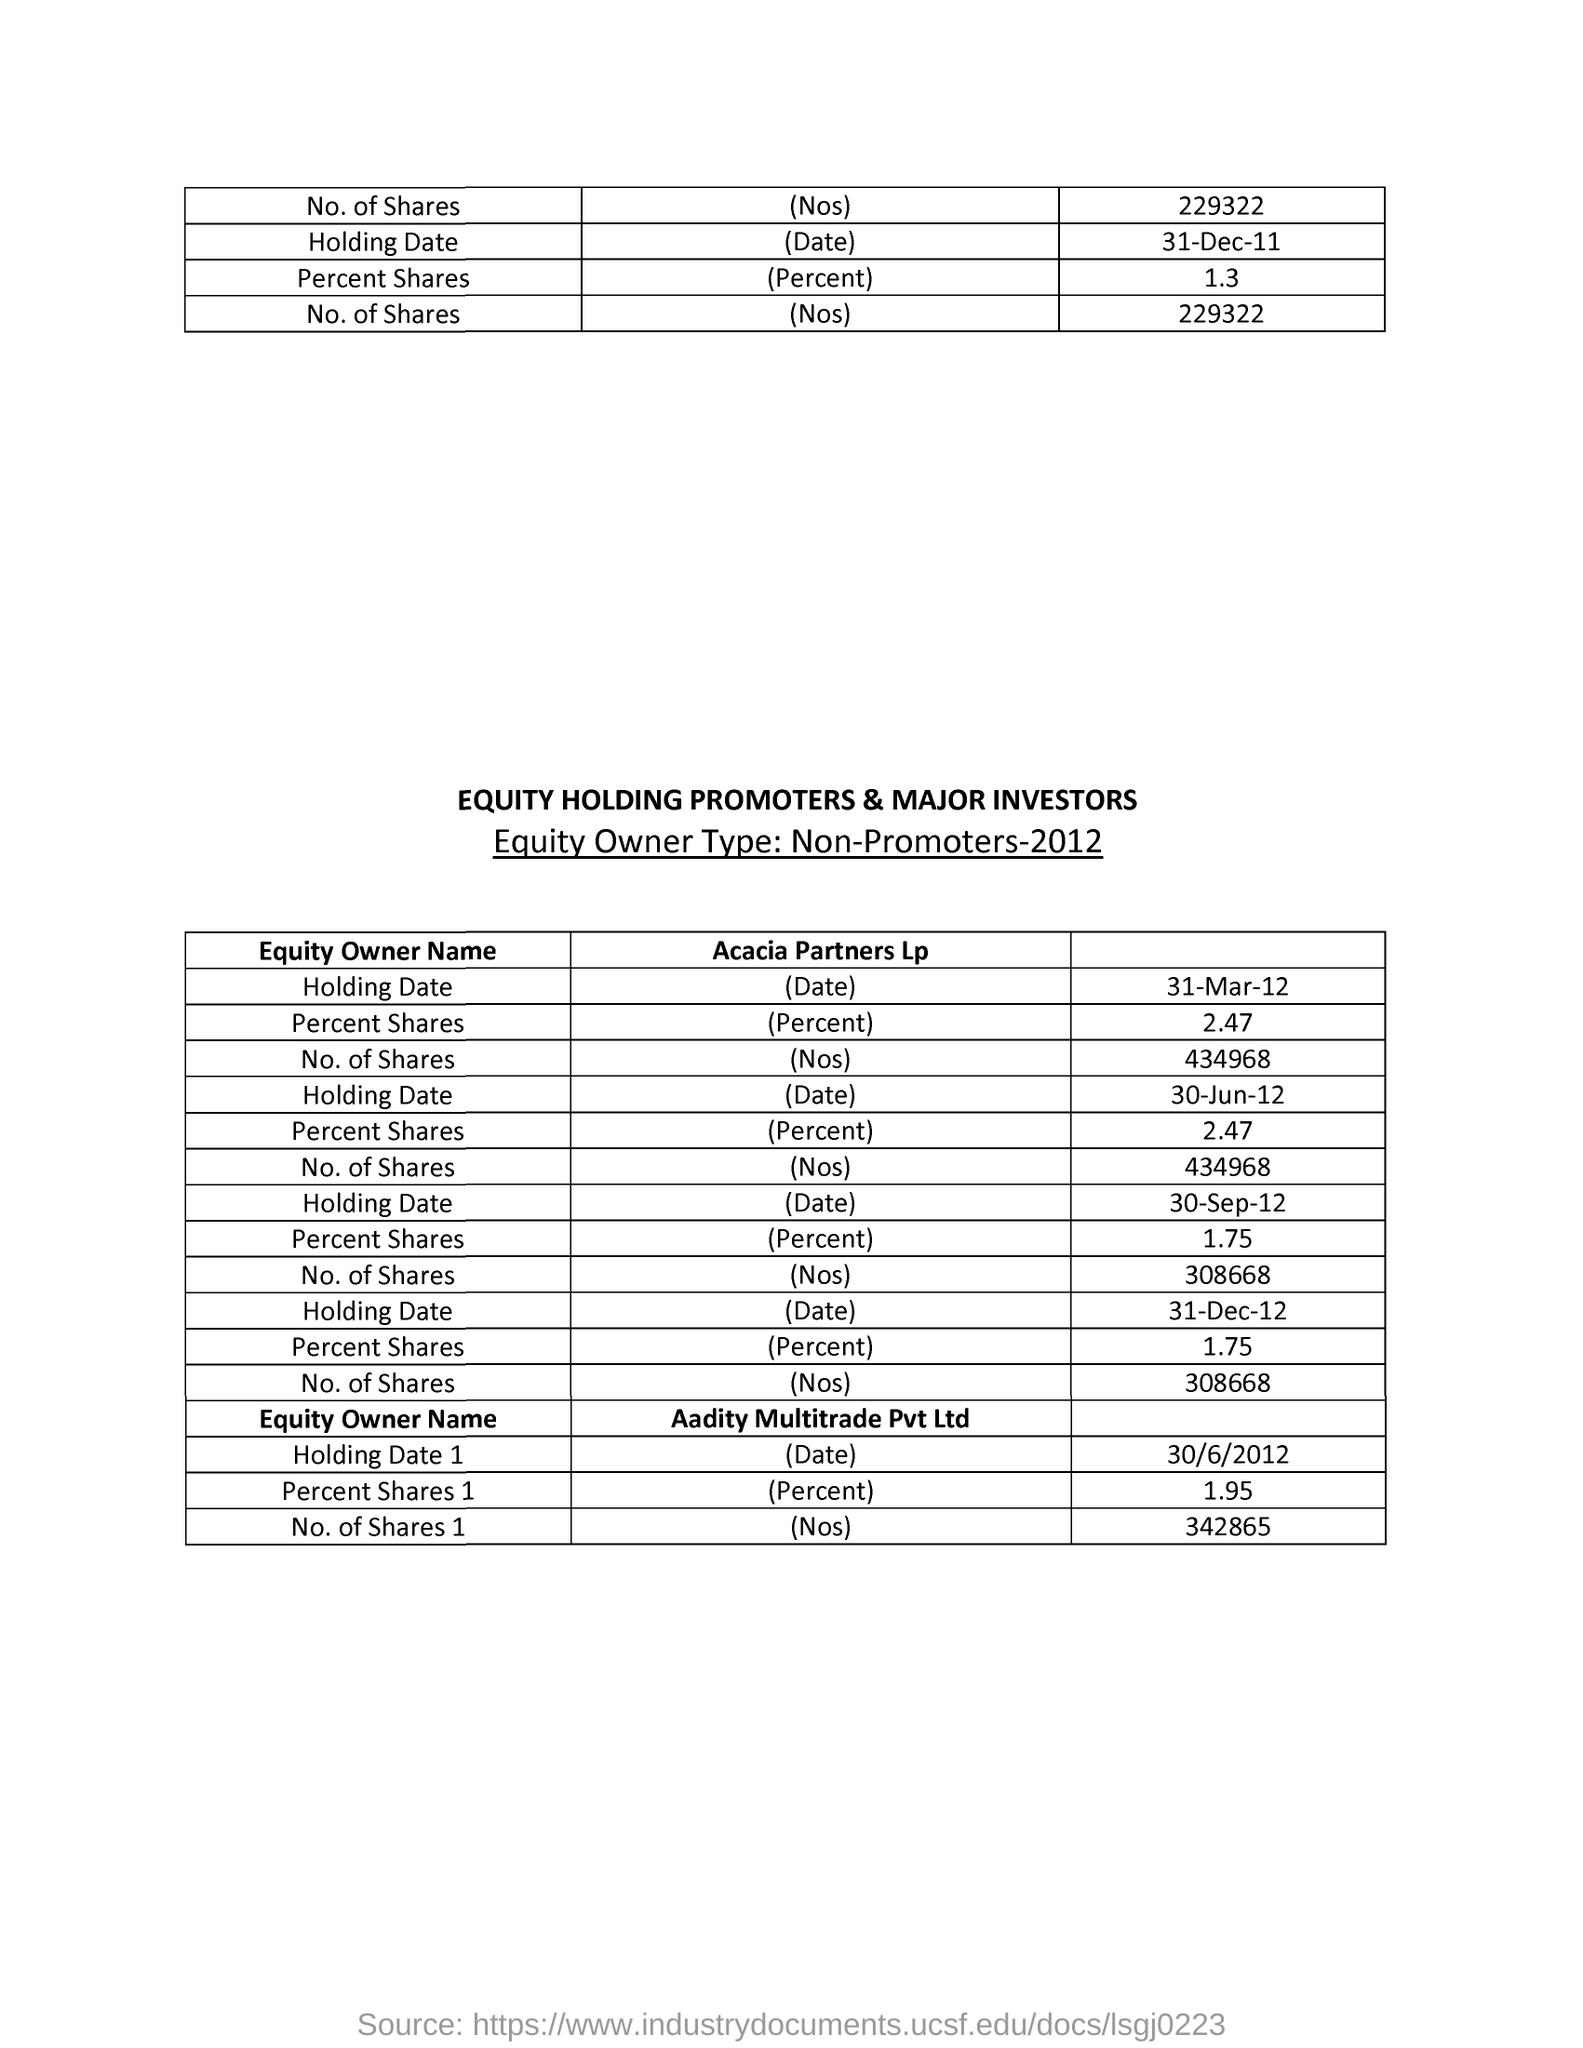What is the percentage of shares held by Acacia Partners Lp on 31-Mar-12?
Your response must be concise. 2.47. What is the number of shares held by Acacia Partners Lp on 31-Mar-12?
Provide a succinct answer. 434968. What is the percentage of shares held by Aadity Multitrade Pvt Ltd on 30/6/2012?
Provide a short and direct response. 1.95. What is the percentage of shares held by Acacia Partners Lp on 31-Dec-12?
Offer a very short reply. 1.75. What is the number of shares held by Acacia Partners Lp on 31-Dec-12?
Your answer should be compact. 308668. 